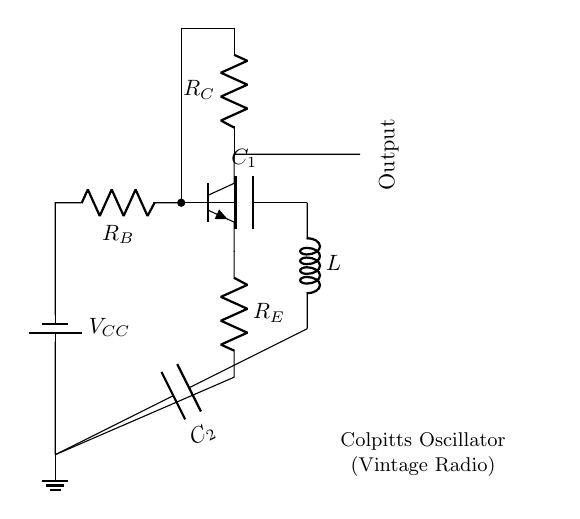What is the type of transistor used in this oscillator? The circuit diagram shows an npn transistor, which can be distinguished by the label "Q1" and the symbols indicating the base, collector, and emitter.
Answer: npn What component provides the main feedback in this Colpitts oscillator? The feedback in a Colpitts oscillator primarily comes from the combination of the capacitors C1 and C2, which form a voltage divider that connects between the collector and base.
Answer: C1 and C2 What is the function of the inductor L in this circuit? In a Colpitts oscillator, the inductor L works with the capacitors to determine the oscillation frequency and forms part of the tank circuit that enables sustained oscillations.
Answer: Frequency determination How many resistors are present in this circuit? The circuit contains three resistors: R_B, R_C, and R_E, which are labeled and show the biasing and stabilization of the transistor.
Answer: three What role does the battery V_CC play in this oscillator circuit? The battery V_CC provides the necessary power supply for the oscillator to function, ensuring that the transistor can operate in the active region to amplify signals.
Answer: Power supply How does the output in this Colpitts oscillator connect to the circuit? The output is connected directly to the collector of the transistor (labeled as 'out') and is marked as the output, indicating that it takes the amplified signal from the transistor.
Answer: Directly from collector What is the primary purpose of the Colpitts oscillator in a vintage radio? The primary purpose of a Colpitts oscillator in a vintage radio is to generate a specific frequency, which can be used for tuning into radio channels, allowing reception of different radio signals.
Answer: Frequency generation 